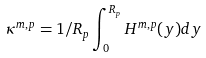<formula> <loc_0><loc_0><loc_500><loc_500>\kappa ^ { m , p } = 1 / R _ { p } \int _ { 0 } ^ { R _ { p } } H ^ { m , p } ( y ) d y</formula> 